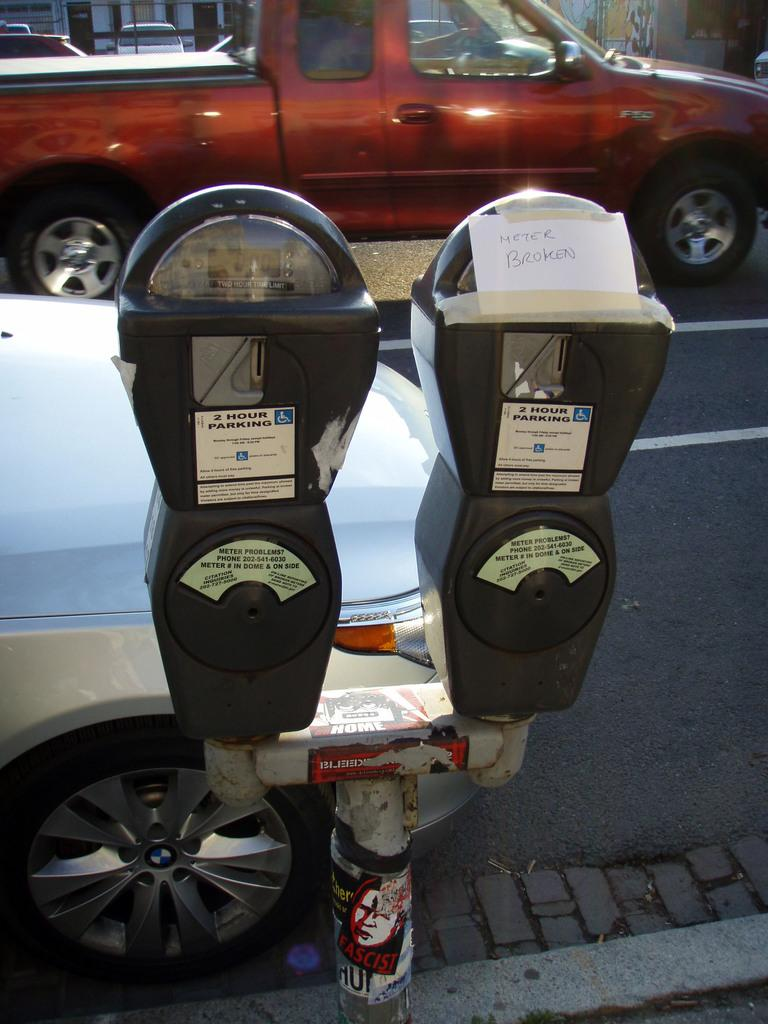<image>
Offer a succinct explanation of the picture presented. Two handicapped parking meters, where on of the meters is out of order. 